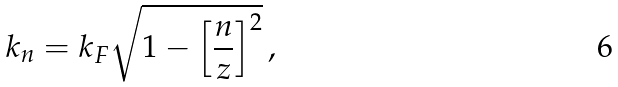<formula> <loc_0><loc_0><loc_500><loc_500>k _ { n } = k _ { F } \sqrt { 1 - \left [ \frac { n } { z } \right ] ^ { 2 } } \, ,</formula> 